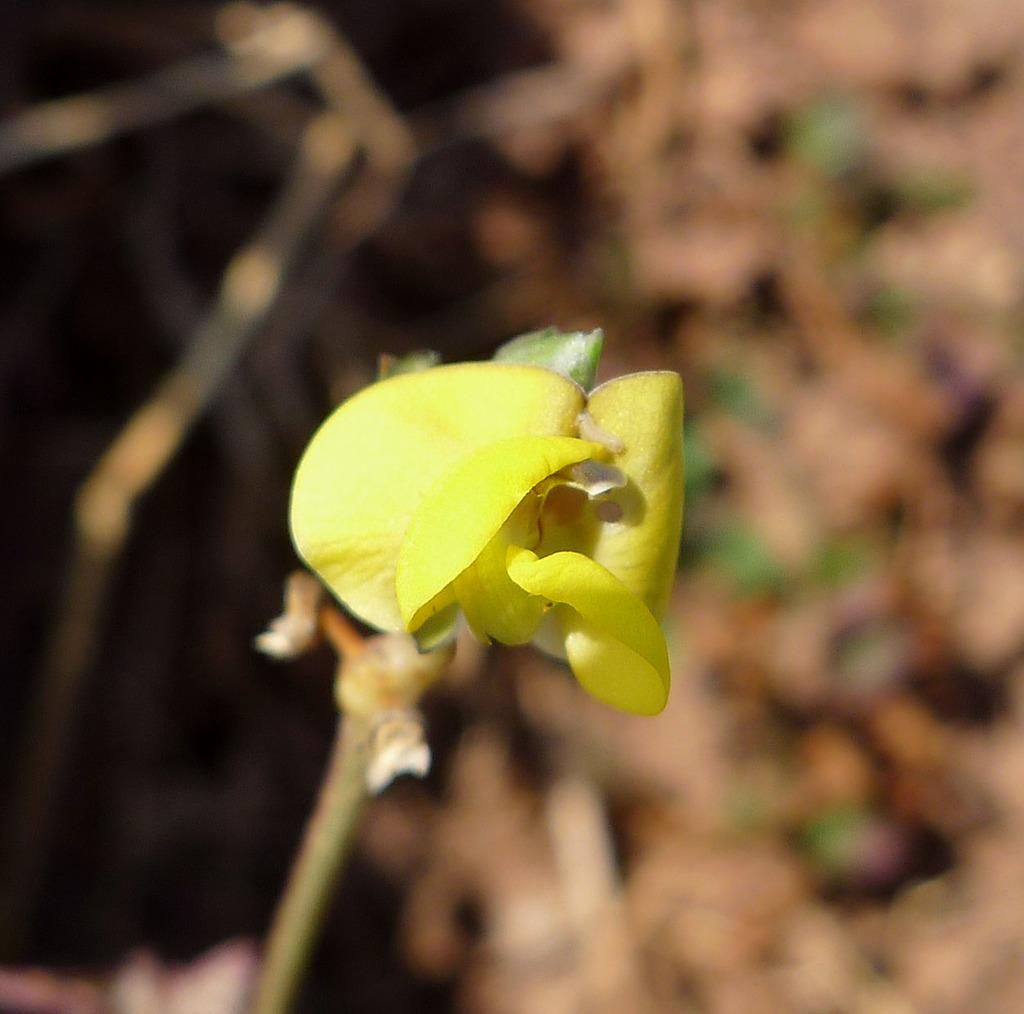What type of flower is present in the image? There is a yellow color flower in the image. Can you describe the background of the image? The background of the image is blurry. Where is the pot located in the image? There is no pot present in the image. What type of bed can be seen in the image? There is no bed present in the image. 